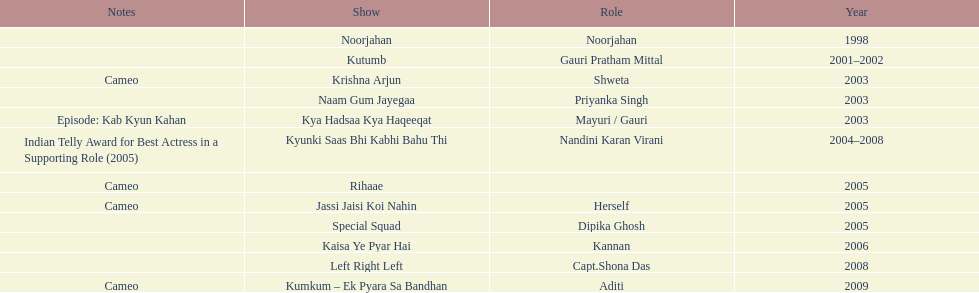In total, how many different tv series has gauri tejwani either starred or cameoed in? 11. 